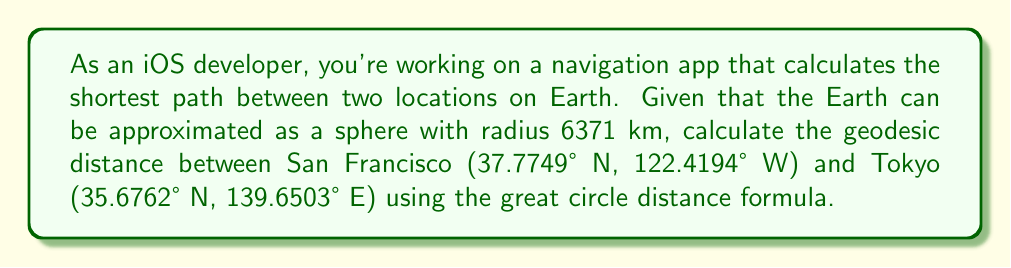Provide a solution to this math problem. To solve this problem, we'll use the Haversine formula, which is commonly used to calculate great circle distances on a sphere. Here's the step-by-step solution:

1. Convert the latitude and longitude coordinates from degrees to radians:
   $$\phi_1 = 37.7749° \times \frac{\pi}{180} = 0.6593 \text{ rad}$$
   $$\lambda_1 = -122.4194° \times \frac{\pi}{180} = -2.1366 \text{ rad}$$
   $$\phi_2 = 35.6762° \times \frac{\pi}{180} = 0.6227 \text{ rad}$$
   $$\lambda_2 = 139.6503° \times \frac{\pi}{180} = 2.4372 \text{ rad}$$

2. Calculate the central angle $\Delta\sigma$ using the Haversine formula:
   $$\Delta\sigma = 2 \arcsin\left(\sqrt{\sin^2\left(\frac{\phi_2 - \phi_1}{2}\right) + \cos\phi_1 \cos\phi_2 \sin^2\left(\frac{\lambda_2 - \lambda_1}{2}\right)}\right)$$

3. Substitute the values:
   $$\Delta\sigma = 2 \arcsin\left(\sqrt{\sin^2\left(\frac{0.6227 - 0.6593}{2}\right) + \cos(0.6593) \cos(0.6227) \sin^2\left(\frac{2.4372 - (-2.1366)}{2}\right)}\right)$$

4. Evaluate the expression:
   $$\Delta\sigma = 2 \arcsin(\sqrt{0.0001 + 0.4641}) = 2 \arcsin(0.6814) = 1.4534 \text{ rad}$$

5. Calculate the geodesic distance $d$ by multiplying the central angle by the Earth's radius:
   $$d = R \times \Delta\sigma = 6371 \text{ km} \times 1.4534 \text{ rad} = 9259.83 \text{ km}$$

Thus, the geodesic distance between San Francisco and Tokyo is approximately 9259.83 km.
Answer: 9259.83 km 